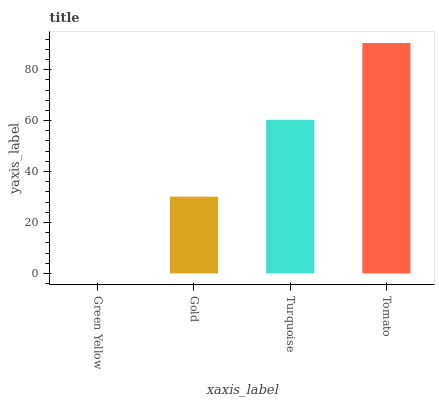Is Green Yellow the minimum?
Answer yes or no. Yes. Is Tomato the maximum?
Answer yes or no. Yes. Is Gold the minimum?
Answer yes or no. No. Is Gold the maximum?
Answer yes or no. No. Is Gold greater than Green Yellow?
Answer yes or no. Yes. Is Green Yellow less than Gold?
Answer yes or no. Yes. Is Green Yellow greater than Gold?
Answer yes or no. No. Is Gold less than Green Yellow?
Answer yes or no. No. Is Turquoise the high median?
Answer yes or no. Yes. Is Gold the low median?
Answer yes or no. Yes. Is Gold the high median?
Answer yes or no. No. Is Green Yellow the low median?
Answer yes or no. No. 